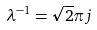Convert formula to latex. <formula><loc_0><loc_0><loc_500><loc_500>\lambda ^ { - 1 } = \sqrt { 2 } \pi j</formula> 